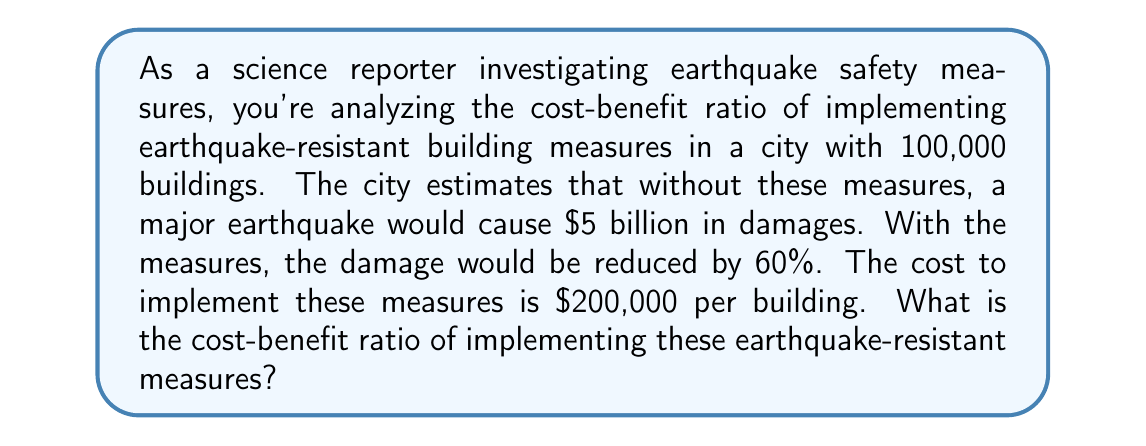Can you answer this question? To solve this problem, we need to follow these steps:

1. Calculate the total cost of implementing the measures:
   Cost = Number of buildings × Cost per building
   $$ C = 100,000 \times \$200,000 = \$20 \text{ billion} $$

2. Calculate the benefit (reduction in damage):
   Benefit = Total potential damage × Reduction percentage
   $$ B = \$5 \text{ billion} \times 0.60 = \$3 \text{ billion} $$

3. Calculate the cost-benefit ratio:
   Cost-Benefit Ratio = Cost ÷ Benefit
   $$ \text{CBR} = \frac{C}{B} = \frac{\$20 \text{ billion}}{\$3 \text{ billion}} = \frac{20}{3} \approx 6.67 $$

The cost-benefit ratio is approximately 6.67, which means that for every $1 of benefit, the cost is $6.67.

In decision theory, a cost-benefit ratio greater than 1 typically indicates that the costs outweigh the benefits. However, in this case, we must consider that the potential to save lives and prevent long-term economic disruption may justify the higher costs, even if they don't directly translate to monetary benefits in this simple calculation.
Answer: The cost-benefit ratio of implementing earthquake-resistant building measures is approximately 6.67. 